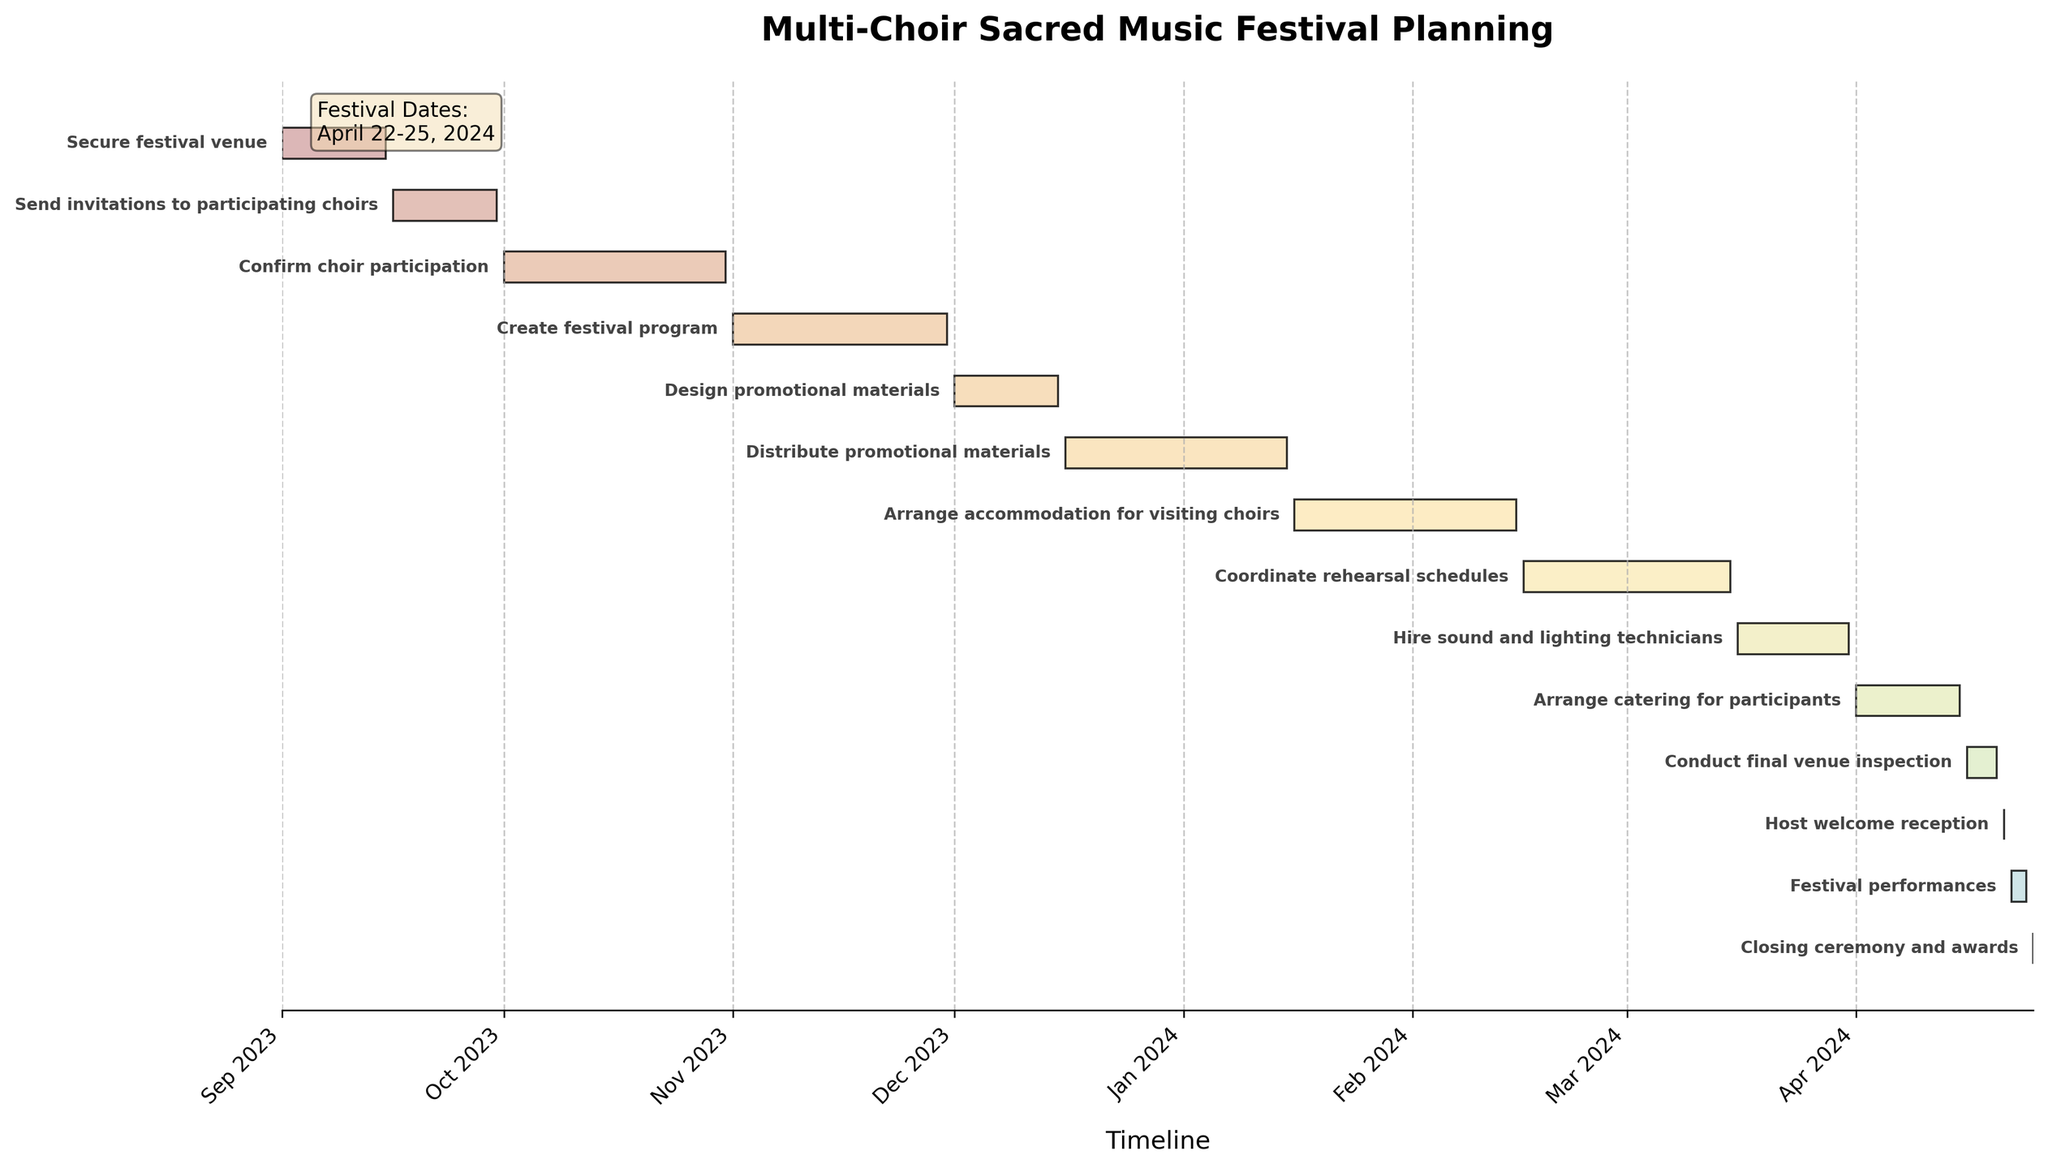What is the title of the chart? The title is usually located at the top of the chart. It describes what the chart is about.
Answer: Multi-Choir Sacred Music Festival Planning How long is the 'Secure festival venue' task scheduled to take? Locate the 'Secure festival venue' task on the chart and check the duration.
Answer: 15 days Which task starts immediately after the 'Send invitations to participating choirs'? Locate the 'Send invitations to participating choirs' task, then identify the next task in sequence on the timeline.
Answer: Confirm choir participation What are the start and end dates for the 'Festival performances'? Find the 'Festival performances' task on the chart and look at the start and end dates.
Answer: April 22, 2024 - April 24, 2024 How many days long is the 'Create festival program' task? Locate the 'Create festival program' task on the chart and calculate the duration based on the start and end dates.
Answer: 30 days When do 'Distribute promotional materials' and 'Arrange accommodation for visiting choirs' tasks start? Look for the start points of these tasks on the timeline.
Answer: December 16, 2023, and January 16, 2024, respectively Does the 'Hire sound and lighting technicians' task overlap with the 'Coordinate rehearsal schedules' task? Compare the start and end dates of both tasks to see if there is any overlap.
Answer: Yes What is the duration of time between the end of 'Confirm choir participation' and the start of 'Create festival program'? Subtract the end date of 'Confirm choir participation' from the start date of 'Create festival program'.
Answer: 1 day Which tasks are scheduled to start in April 2024? Identify tasks on the chart that have start dates in April 2024.
Answer: Arrange catering for participants, Conduct final venue inspection, Host welcome reception, Festival performances, Closing ceremony and awards Which task has the shortest duration and what is it? Scan the durations of all tasks and identify the shortest one.
Answer: Host welcome reception and Closing ceremony and awards, both 1 day 